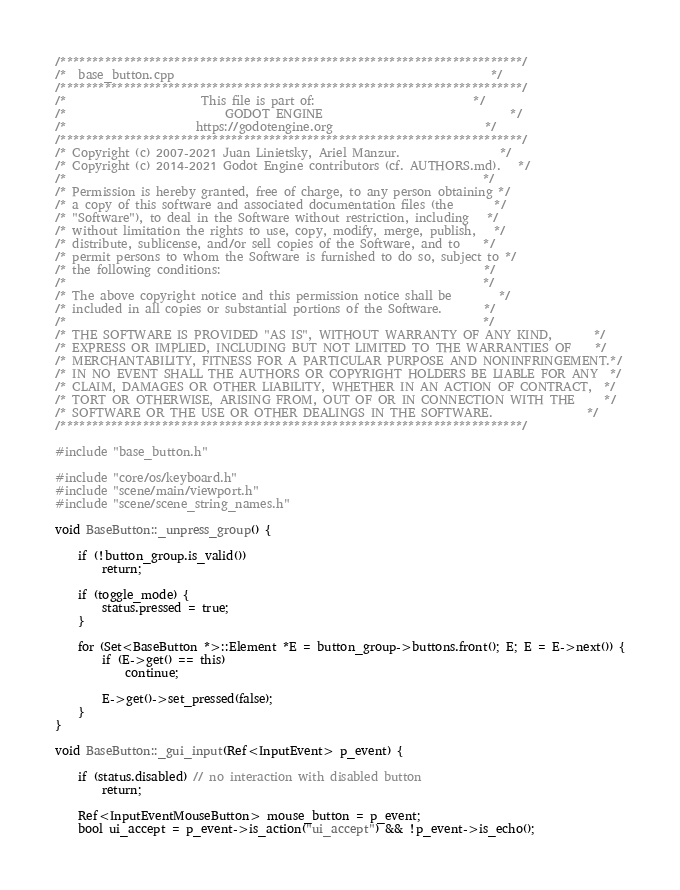Convert code to text. <code><loc_0><loc_0><loc_500><loc_500><_C++_>/*************************************************************************/
/*  base_button.cpp                                                      */
/*************************************************************************/
/*                       This file is part of:                           */
/*                           GODOT ENGINE                                */
/*                      https://godotengine.org                          */
/*************************************************************************/
/* Copyright (c) 2007-2021 Juan Linietsky, Ariel Manzur.                 */
/* Copyright (c) 2014-2021 Godot Engine contributors (cf. AUTHORS.md).   */
/*                                                                       */
/* Permission is hereby granted, free of charge, to any person obtaining */
/* a copy of this software and associated documentation files (the       */
/* "Software"), to deal in the Software without restriction, including   */
/* without limitation the rights to use, copy, modify, merge, publish,   */
/* distribute, sublicense, and/or sell copies of the Software, and to    */
/* permit persons to whom the Software is furnished to do so, subject to */
/* the following conditions:                                             */
/*                                                                       */
/* The above copyright notice and this permission notice shall be        */
/* included in all copies or substantial portions of the Software.       */
/*                                                                       */
/* THE SOFTWARE IS PROVIDED "AS IS", WITHOUT WARRANTY OF ANY KIND,       */
/* EXPRESS OR IMPLIED, INCLUDING BUT NOT LIMITED TO THE WARRANTIES OF    */
/* MERCHANTABILITY, FITNESS FOR A PARTICULAR PURPOSE AND NONINFRINGEMENT.*/
/* IN NO EVENT SHALL THE AUTHORS OR COPYRIGHT HOLDERS BE LIABLE FOR ANY  */
/* CLAIM, DAMAGES OR OTHER LIABILITY, WHETHER IN AN ACTION OF CONTRACT,  */
/* TORT OR OTHERWISE, ARISING FROM, OUT OF OR IN CONNECTION WITH THE     */
/* SOFTWARE OR THE USE OR OTHER DEALINGS IN THE SOFTWARE.                */
/*************************************************************************/

#include "base_button.h"

#include "core/os/keyboard.h"
#include "scene/main/viewport.h"
#include "scene/scene_string_names.h"

void BaseButton::_unpress_group() {

	if (!button_group.is_valid())
		return;

	if (toggle_mode) {
		status.pressed = true;
	}

	for (Set<BaseButton *>::Element *E = button_group->buttons.front(); E; E = E->next()) {
		if (E->get() == this)
			continue;

		E->get()->set_pressed(false);
	}
}

void BaseButton::_gui_input(Ref<InputEvent> p_event) {

	if (status.disabled) // no interaction with disabled button
		return;

	Ref<InputEventMouseButton> mouse_button = p_event;
	bool ui_accept = p_event->is_action("ui_accept") && !p_event->is_echo();
</code> 